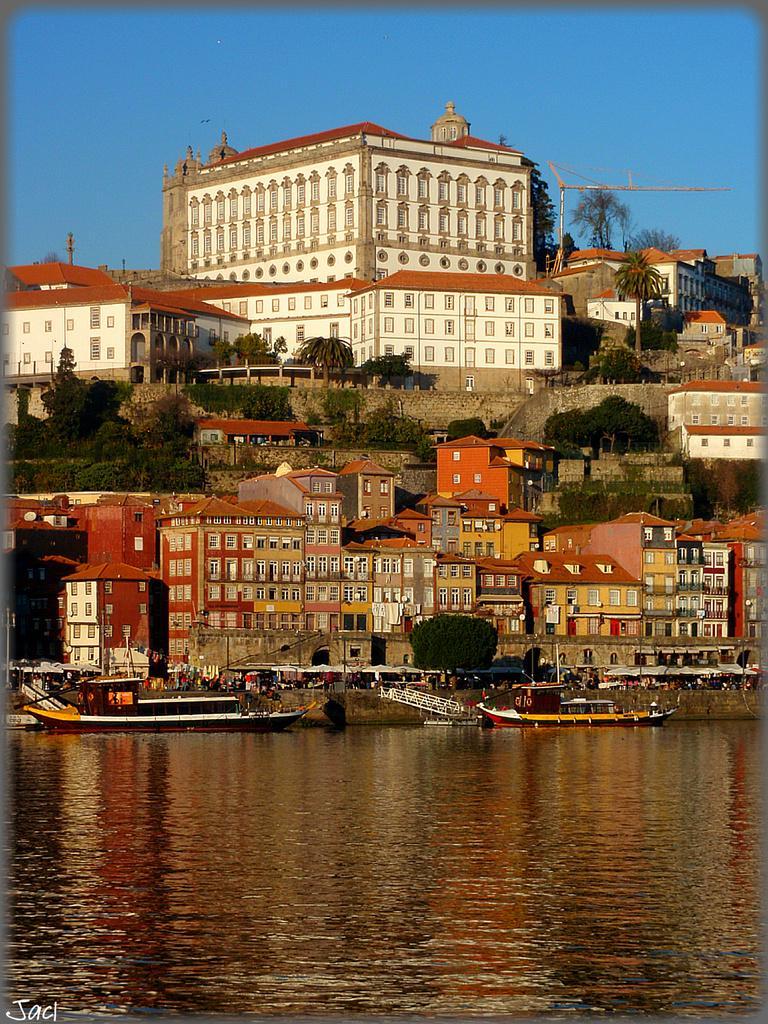Please provide a concise description of this image. In this image we can see boats on the water. In the background we can see few persons, buildings, trees, windows, walls, poles and the sky. 